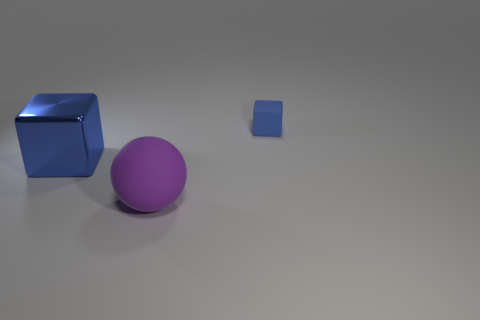Does the cube to the left of the small matte object have the same color as the matte thing behind the shiny thing?
Provide a short and direct response. Yes. There is a blue thing to the right of the blue cube that is to the left of the purple rubber sphere; is there a rubber object in front of it?
Ensure brevity in your answer.  Yes. What material is the small blue cube?
Your answer should be very brief. Rubber. How many other things are there of the same shape as the big matte thing?
Ensure brevity in your answer.  0. Is the tiny rubber thing the same shape as the metallic object?
Keep it short and to the point. Yes. How many objects are objects that are on the right side of the big shiny thing or things that are behind the ball?
Keep it short and to the point. 3. How many objects are tiny things or blue metal things?
Offer a very short reply. 2. How many blue matte cubes are behind the blue object in front of the small cube?
Your answer should be compact. 1. What number of other objects are the same size as the purple thing?
Provide a short and direct response. 1. There is a cube that is the same color as the small object; what size is it?
Your answer should be compact. Large. 